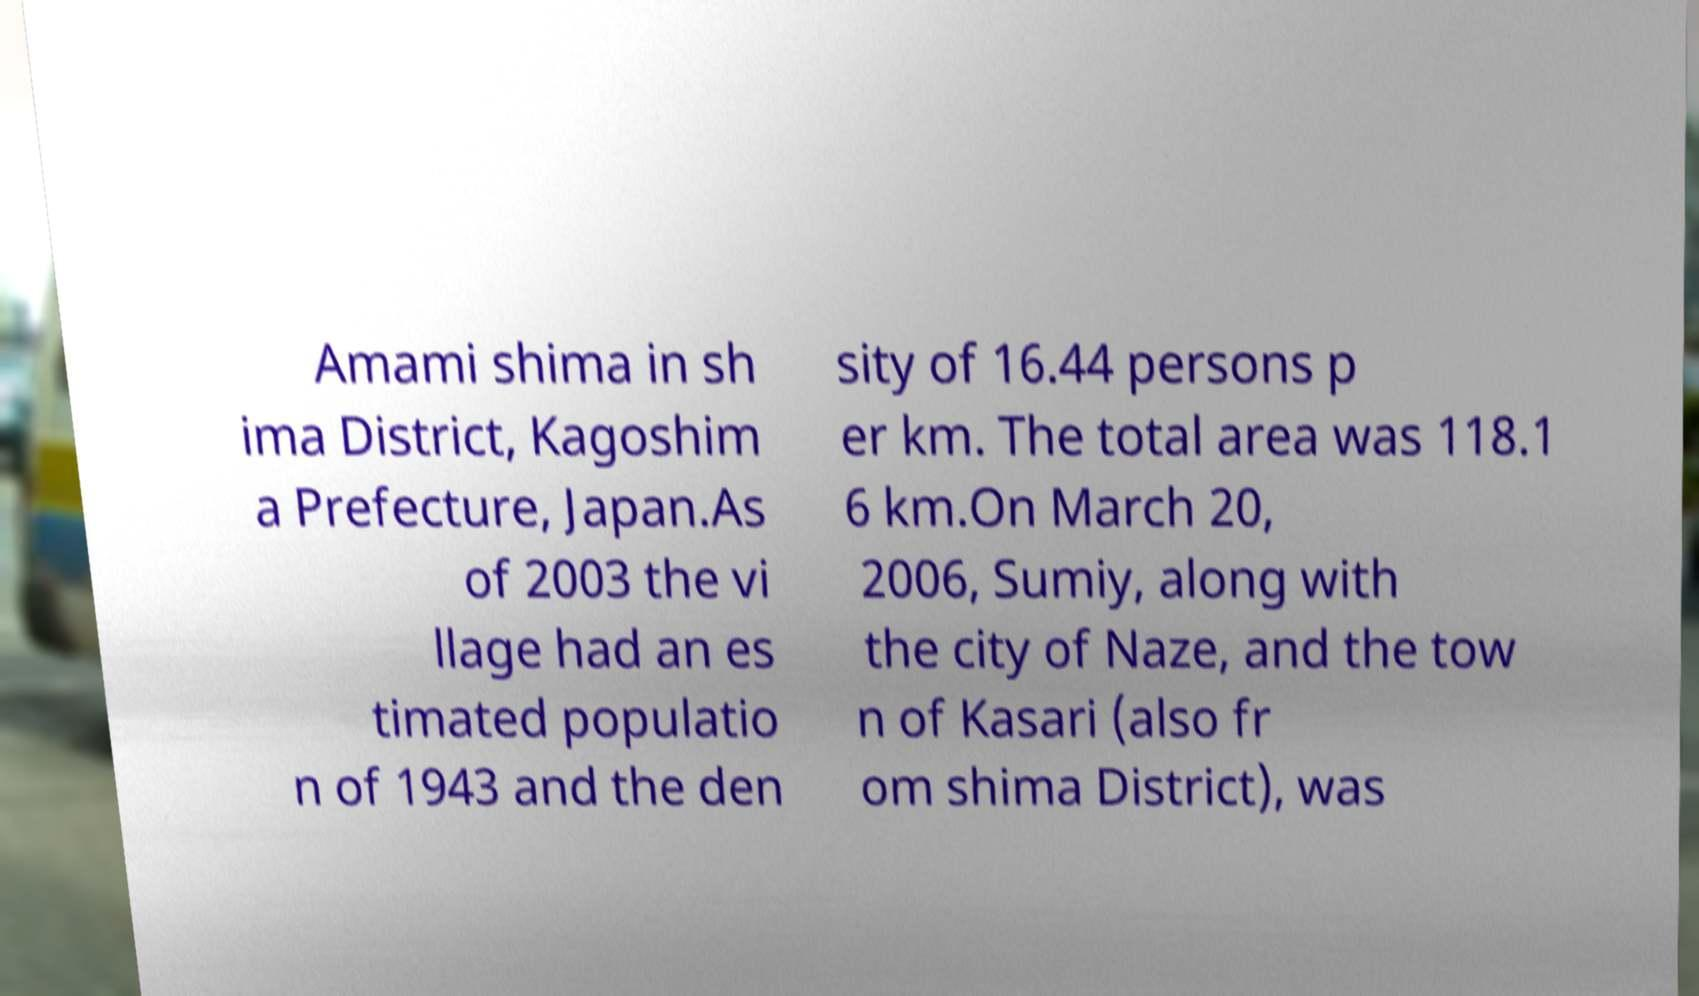Please identify and transcribe the text found in this image. Amami shima in sh ima District, Kagoshim a Prefecture, Japan.As of 2003 the vi llage had an es timated populatio n of 1943 and the den sity of 16.44 persons p er km. The total area was 118.1 6 km.On March 20, 2006, Sumiy, along with the city of Naze, and the tow n of Kasari (also fr om shima District), was 